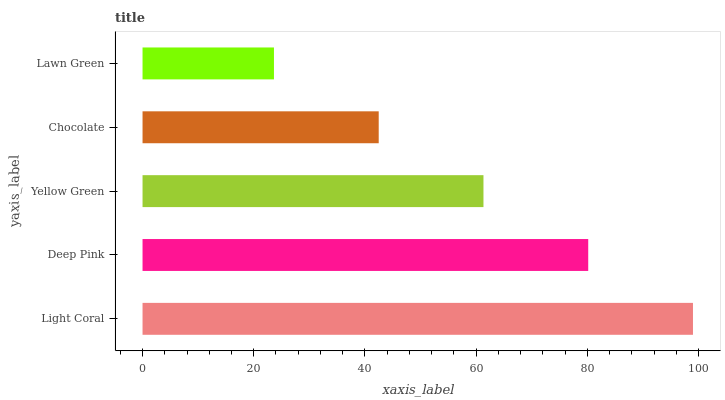Is Lawn Green the minimum?
Answer yes or no. Yes. Is Light Coral the maximum?
Answer yes or no. Yes. Is Deep Pink the minimum?
Answer yes or no. No. Is Deep Pink the maximum?
Answer yes or no. No. Is Light Coral greater than Deep Pink?
Answer yes or no. Yes. Is Deep Pink less than Light Coral?
Answer yes or no. Yes. Is Deep Pink greater than Light Coral?
Answer yes or no. No. Is Light Coral less than Deep Pink?
Answer yes or no. No. Is Yellow Green the high median?
Answer yes or no. Yes. Is Yellow Green the low median?
Answer yes or no. Yes. Is Chocolate the high median?
Answer yes or no. No. Is Light Coral the low median?
Answer yes or no. No. 